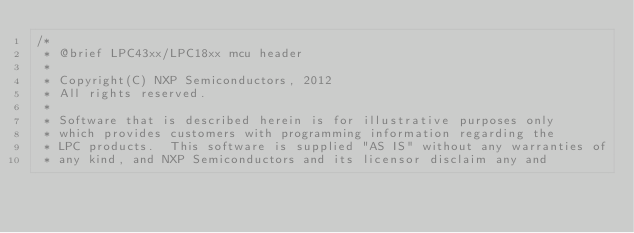Convert code to text. <code><loc_0><loc_0><loc_500><loc_500><_C_>/*
 * @brief LPC43xx/LPC18xx mcu header
 *
 * Copyright(C) NXP Semiconductors, 2012
 * All rights reserved.
 *
 * Software that is described herein is for illustrative purposes only
 * which provides customers with programming information regarding the
 * LPC products.  This software is supplied "AS IS" without any warranties of
 * any kind, and NXP Semiconductors and its licensor disclaim any and</code> 